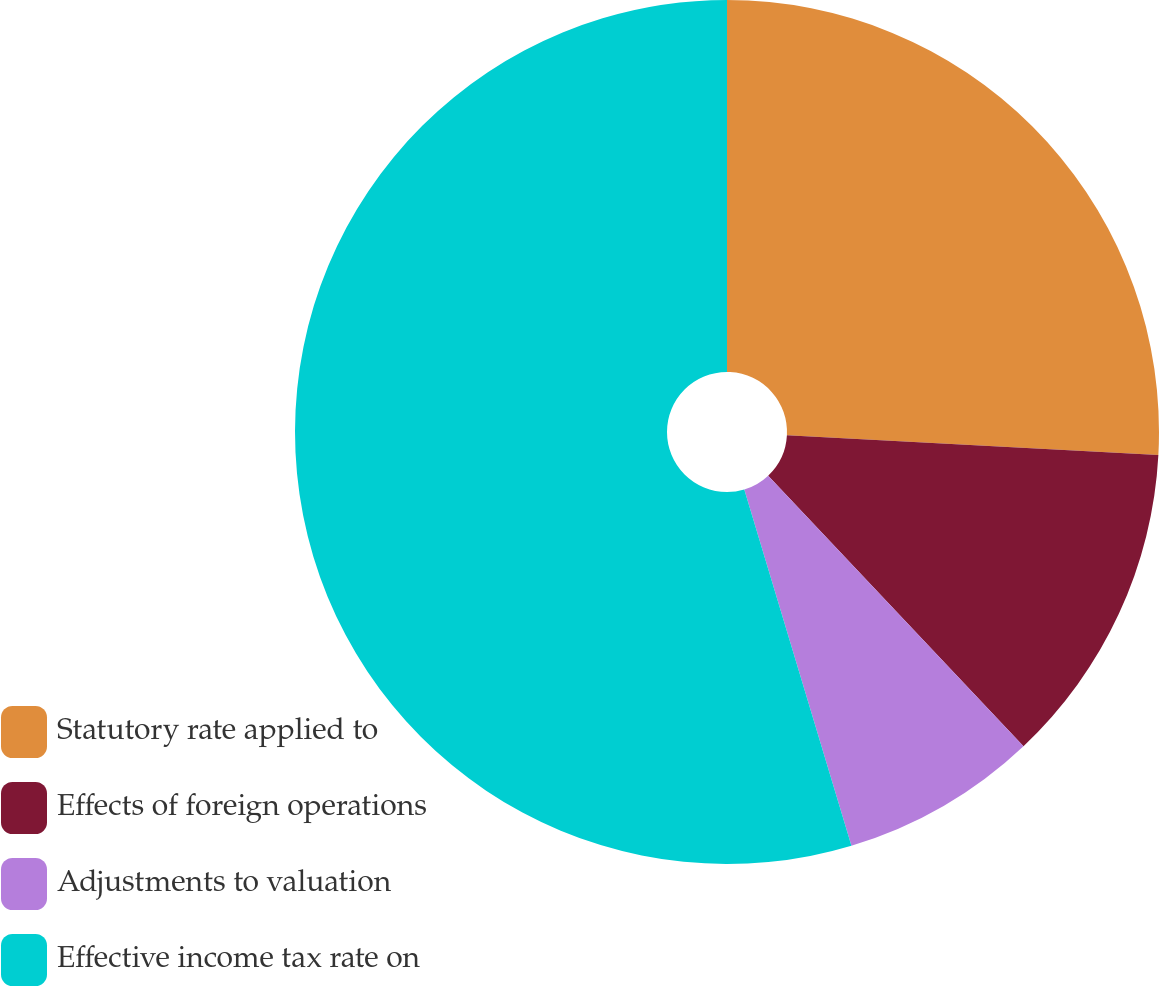Convert chart to OTSL. <chart><loc_0><loc_0><loc_500><loc_500><pie_chart><fcel>Statutory rate applied to<fcel>Effects of foreign operations<fcel>Adjustments to valuation<fcel>Effective income tax rate on<nl><fcel>25.85%<fcel>12.11%<fcel>7.39%<fcel>54.65%<nl></chart> 